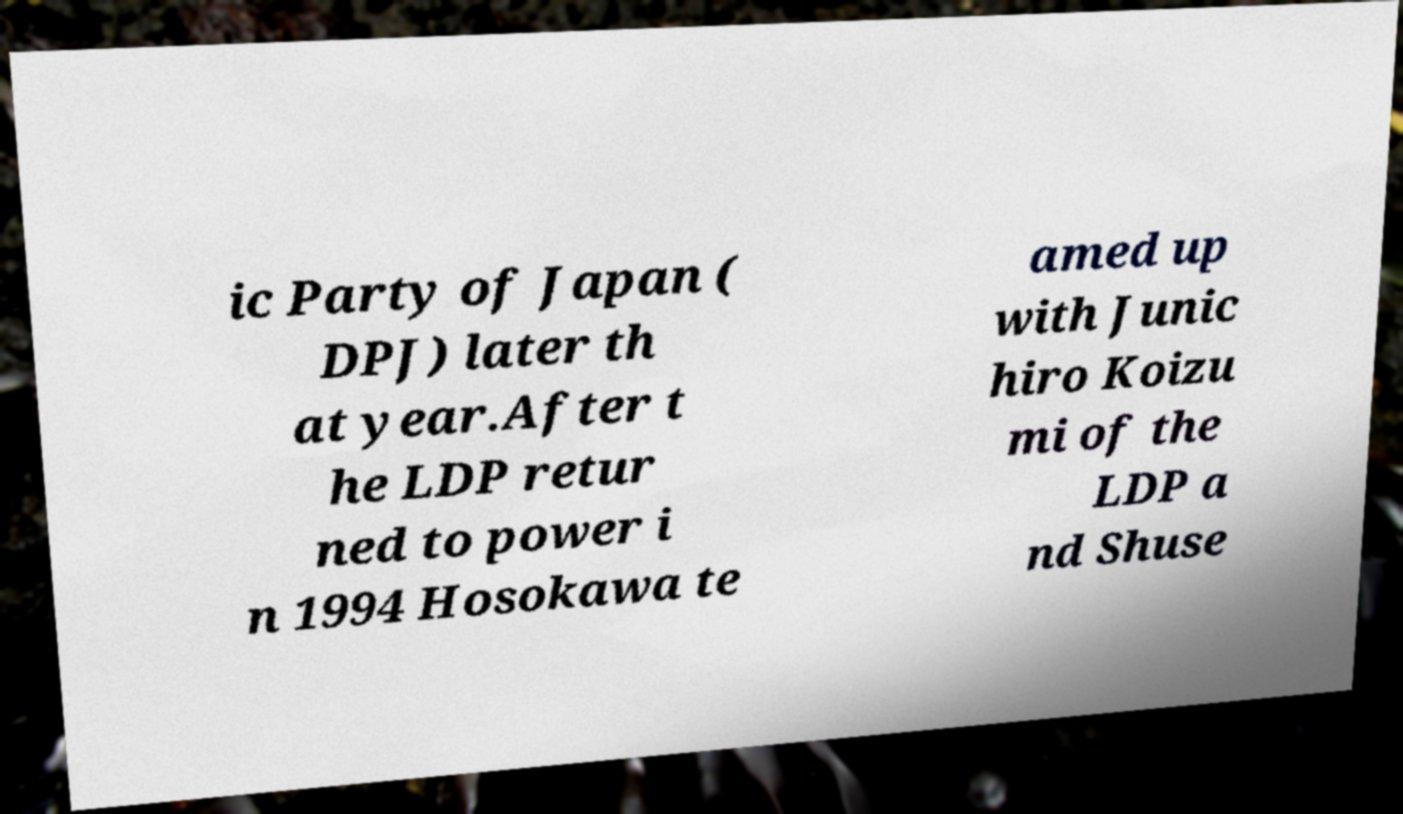Could you extract and type out the text from this image? ic Party of Japan ( DPJ) later th at year.After t he LDP retur ned to power i n 1994 Hosokawa te amed up with Junic hiro Koizu mi of the LDP a nd Shuse 